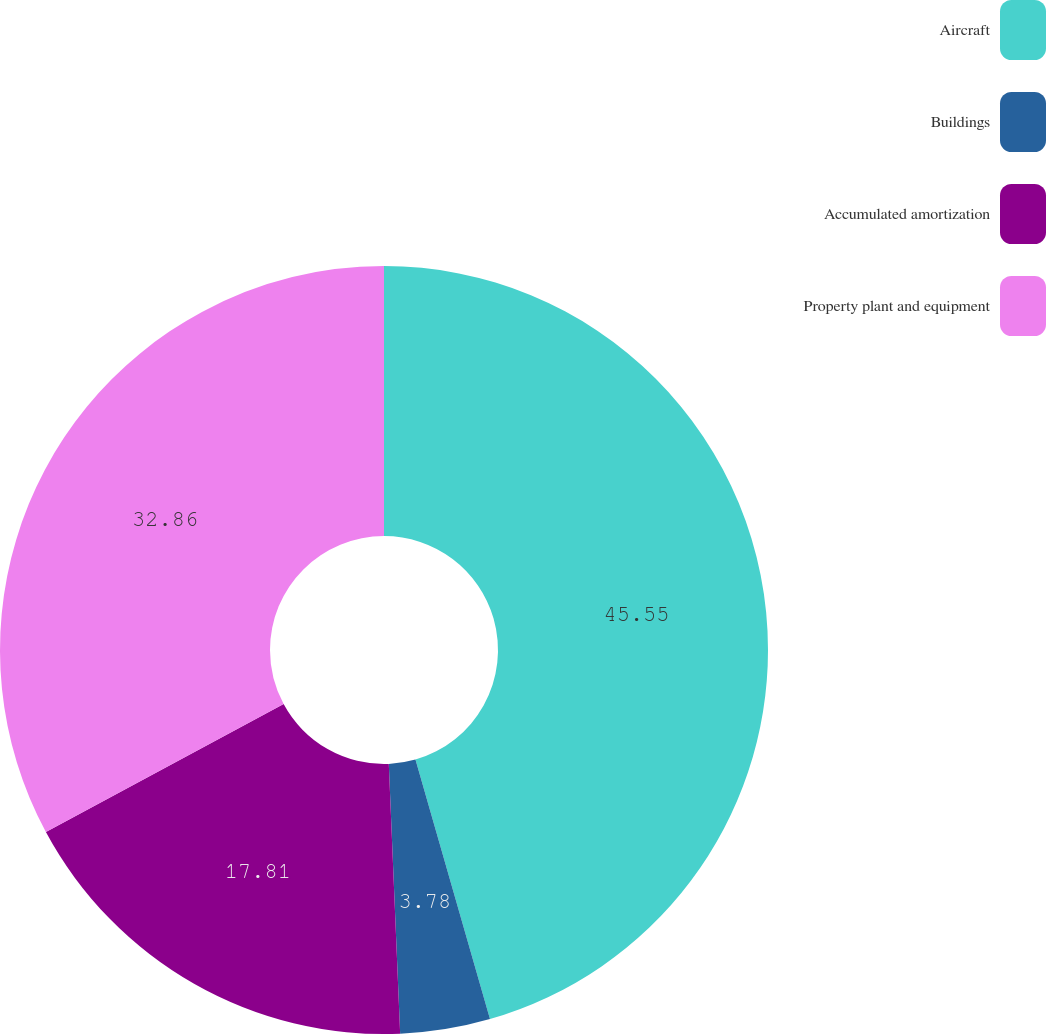Convert chart to OTSL. <chart><loc_0><loc_0><loc_500><loc_500><pie_chart><fcel>Aircraft<fcel>Buildings<fcel>Accumulated amortization<fcel>Property plant and equipment<nl><fcel>45.55%<fcel>3.78%<fcel>17.81%<fcel>32.86%<nl></chart> 